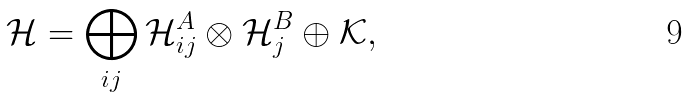<formula> <loc_0><loc_0><loc_500><loc_500>\mathcal { H } = \bigoplus _ { i j } \mathcal { H } ^ { A } _ { i j } \otimes \mathcal { H } ^ { B } _ { j } \oplus \mathcal { K } ,</formula> 